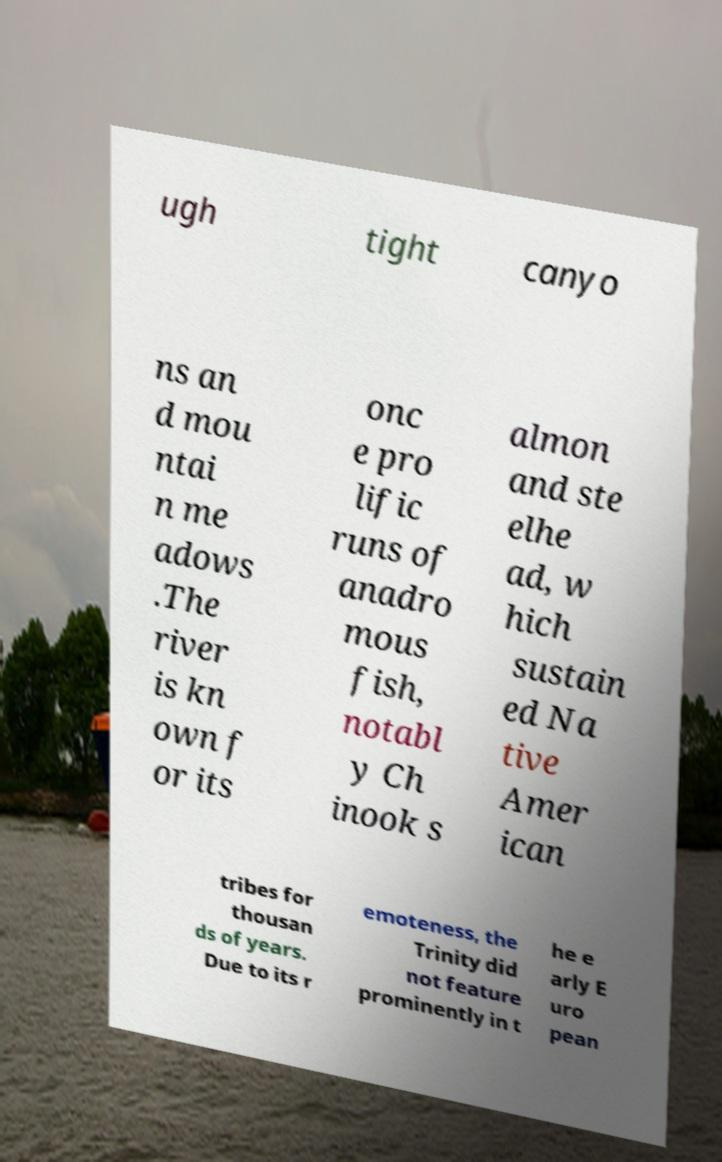Could you assist in decoding the text presented in this image and type it out clearly? ugh tight canyo ns an d mou ntai n me adows .The river is kn own f or its onc e pro lific runs of anadro mous fish, notabl y Ch inook s almon and ste elhe ad, w hich sustain ed Na tive Amer ican tribes for thousan ds of years. Due to its r emoteness, the Trinity did not feature prominently in t he e arly E uro pean 